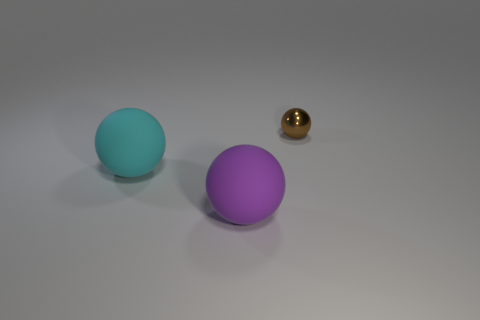The brown thing that is the same shape as the large purple matte object is what size? The brown object, which shares its spherical shape with the larger purple sphere, appears to be quite small in comparison, especially when considering the perspective and relative sizes of the objects depicted in the image. 